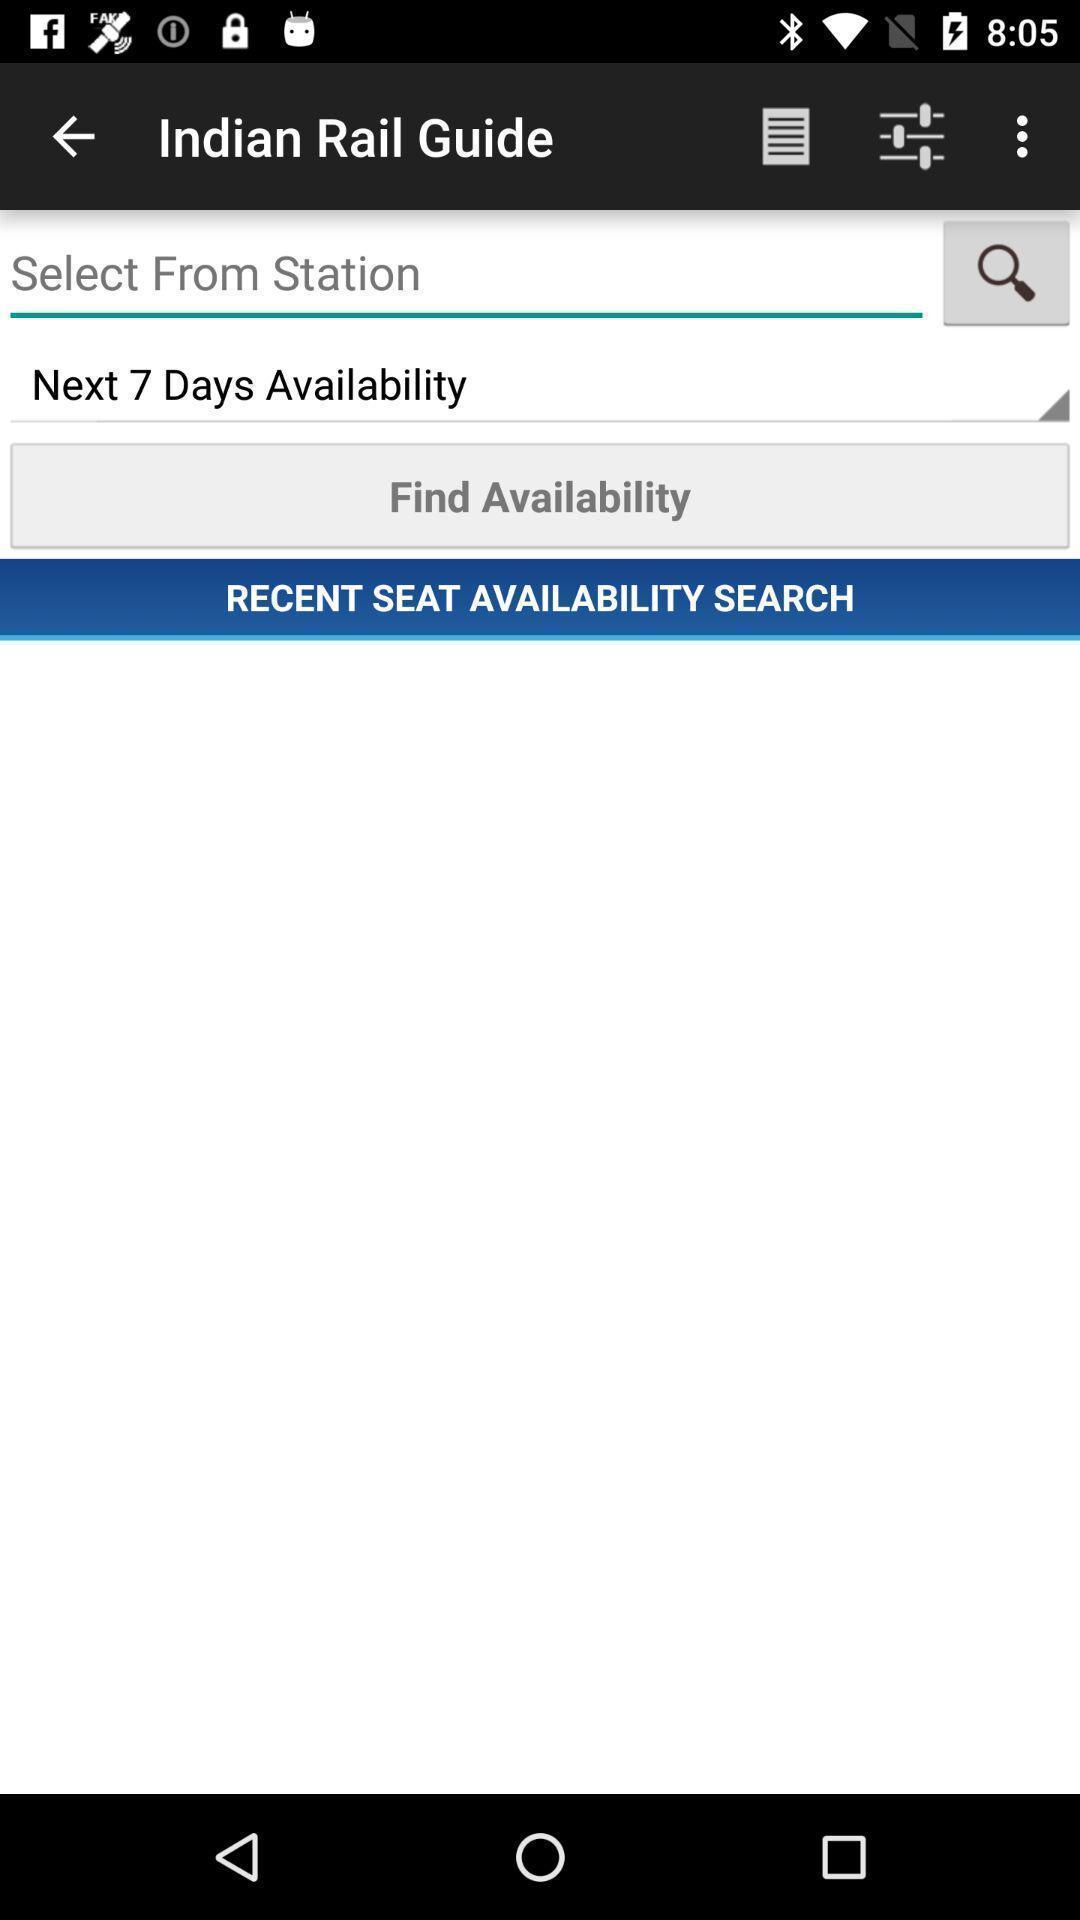Provide a description of this screenshot. Search page displayed for seat availability of a transportation app. 